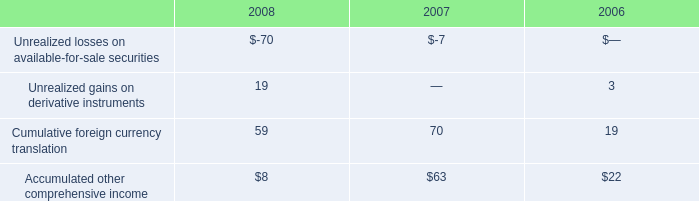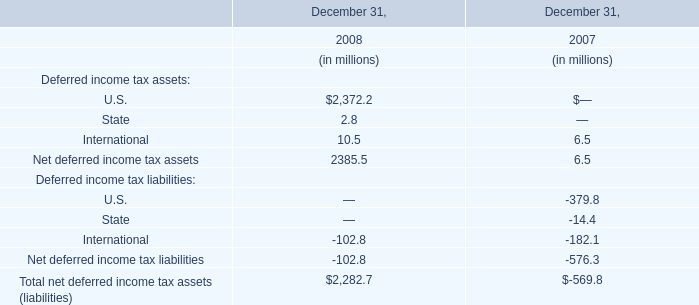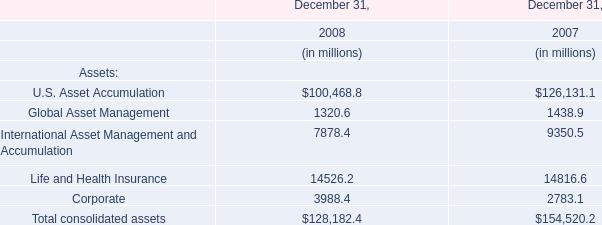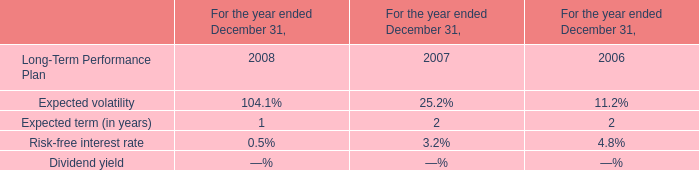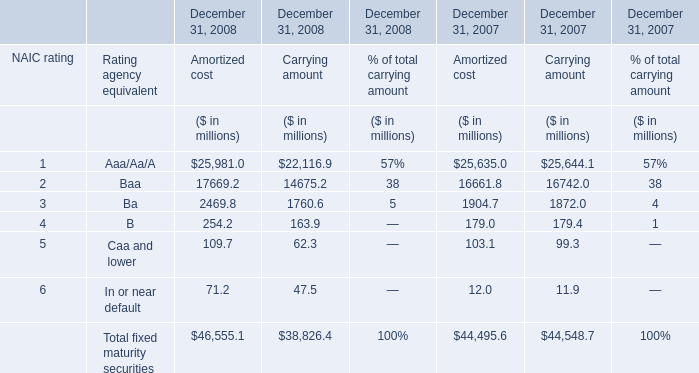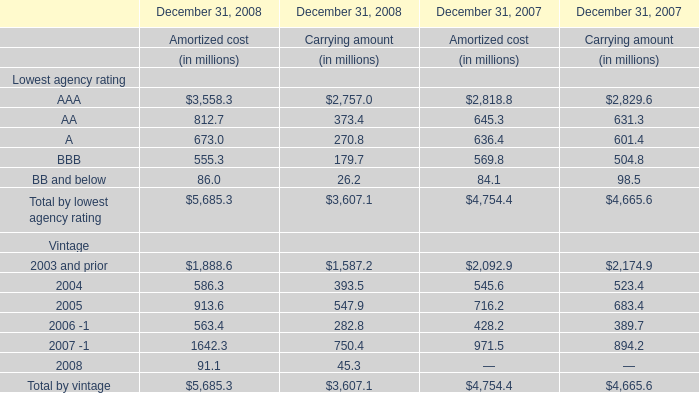What's the growth rate of the Carrying amount of Total fixed maturity securities at December 31, 2008? 
Computations: ((38826.4 - 44548.7) / 44548.7)
Answer: -0.12845. 